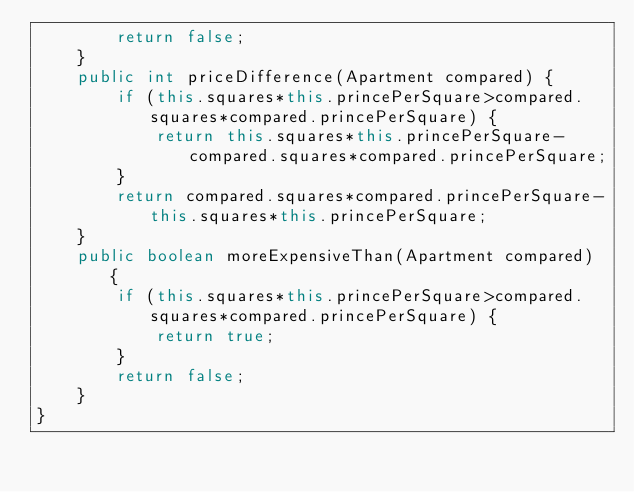Convert code to text. <code><loc_0><loc_0><loc_500><loc_500><_Java_>        return false;
    }
    public int priceDifference(Apartment compared) {
        if (this.squares*this.princePerSquare>compared.squares*compared.princePerSquare) {
            return this.squares*this.princePerSquare-compared.squares*compared.princePerSquare;
        }
        return compared.squares*compared.princePerSquare-this.squares*this.princePerSquare;
    }
    public boolean moreExpensiveThan(Apartment compared) {
        if (this.squares*this.princePerSquare>compared.squares*compared.princePerSquare) {
            return true;
        }
        return false;
    }
}
</code> 